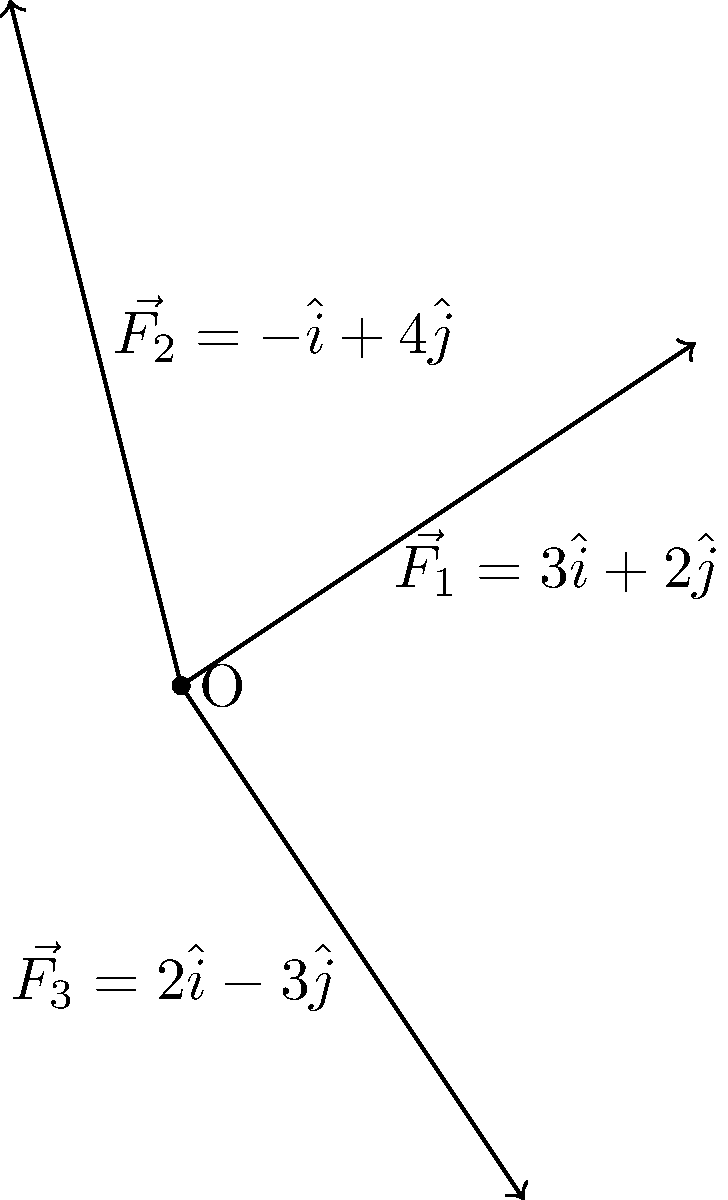During a training session, Coach Osterberger explains that three forces are acting on you simultaneously: $\vec{F_1} = 3\hat{i} + 2\hat{j}$, $\vec{F_2} = -\hat{i} + 4\hat{j}$, and $\vec{F_3} = 2\hat{i} - 3\hat{j}$ (all in Newtons). Calculate the magnitude of the resultant force vector. To find the magnitude of the resultant force vector, we'll follow these steps:

1) First, we need to add all the force vectors to get the resultant force vector $\vec{R}$:

   $\vec{R} = \vec{F_1} + \vec{F_2} + \vec{F_3}$

2) Let's add the i-components and j-components separately:

   i-component: $3 + (-1) + 2 = 4$
   j-component: $2 + 4 + (-3) = 3$

3) So, the resultant force vector is:

   $\vec{R} = 4\hat{i} + 3\hat{j}$

4) To find the magnitude of $\vec{R}$, we use the Pythagorean theorem:

   $|\vec{R}| = \sqrt{(4)^2 + (3)^2}$

5) Simplify:

   $|\vec{R}| = \sqrt{16 + 9} = \sqrt{25} = 5$

Therefore, the magnitude of the resultant force vector is 5 Newtons.
Answer: 5 N 